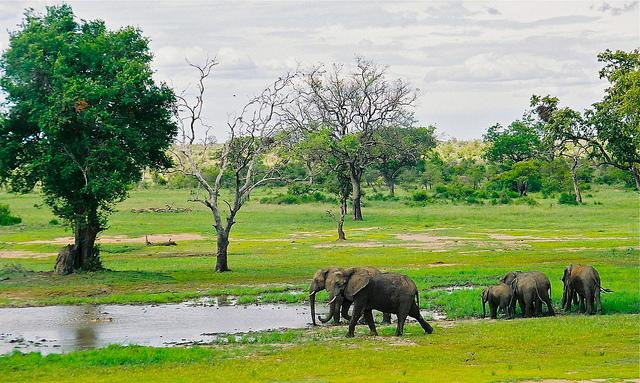What is next to the elephant? Please explain your reasoning. water. Elephants gather at a small water source. 